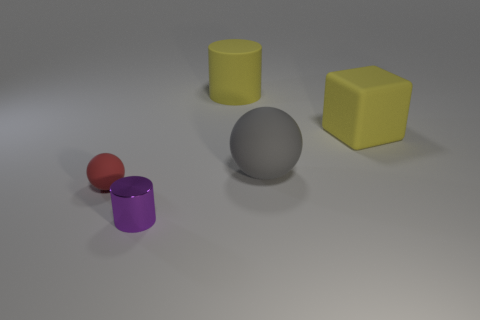Are there any other things that have the same material as the small purple object?
Offer a very short reply. No. What size is the yellow matte thing that is on the right side of the sphere that is right of the thing that is in front of the small ball?
Your answer should be very brief. Large. What material is the red thing?
Keep it short and to the point. Rubber. What is the material of the purple thing that is the same size as the red thing?
Give a very brief answer. Metal. Does the large yellow object that is in front of the matte cylinder have the same material as the big yellow thing that is behind the big yellow rubber block?
Make the answer very short. Yes. There is another object that is the same size as the shiny object; what is its shape?
Provide a short and direct response. Sphere. What number of other objects are the same color as the small rubber sphere?
Make the answer very short. 0. There is a matte cube to the right of the tiny red ball; what color is it?
Your answer should be compact. Yellow. What number of other things are made of the same material as the large gray thing?
Offer a terse response. 3. Are there more large blocks in front of the large matte cylinder than large rubber spheres right of the big gray rubber thing?
Ensure brevity in your answer.  Yes. 